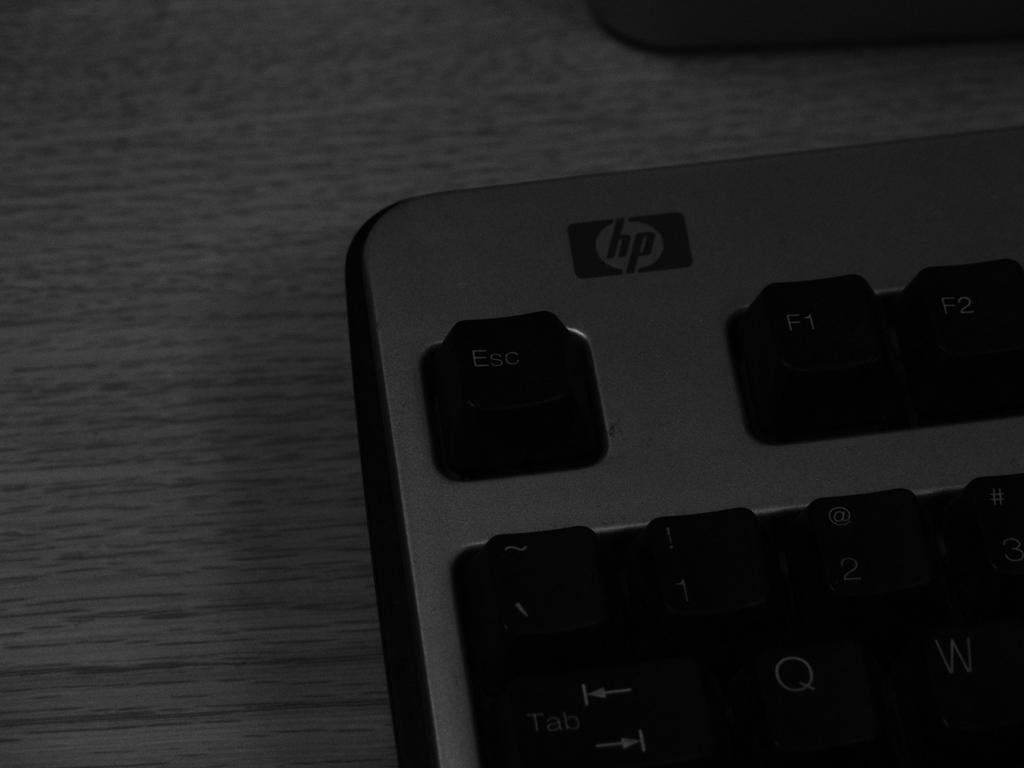<image>
Summarize the visual content of the image. The top right of an HP computer keyboard near the ESC button. 